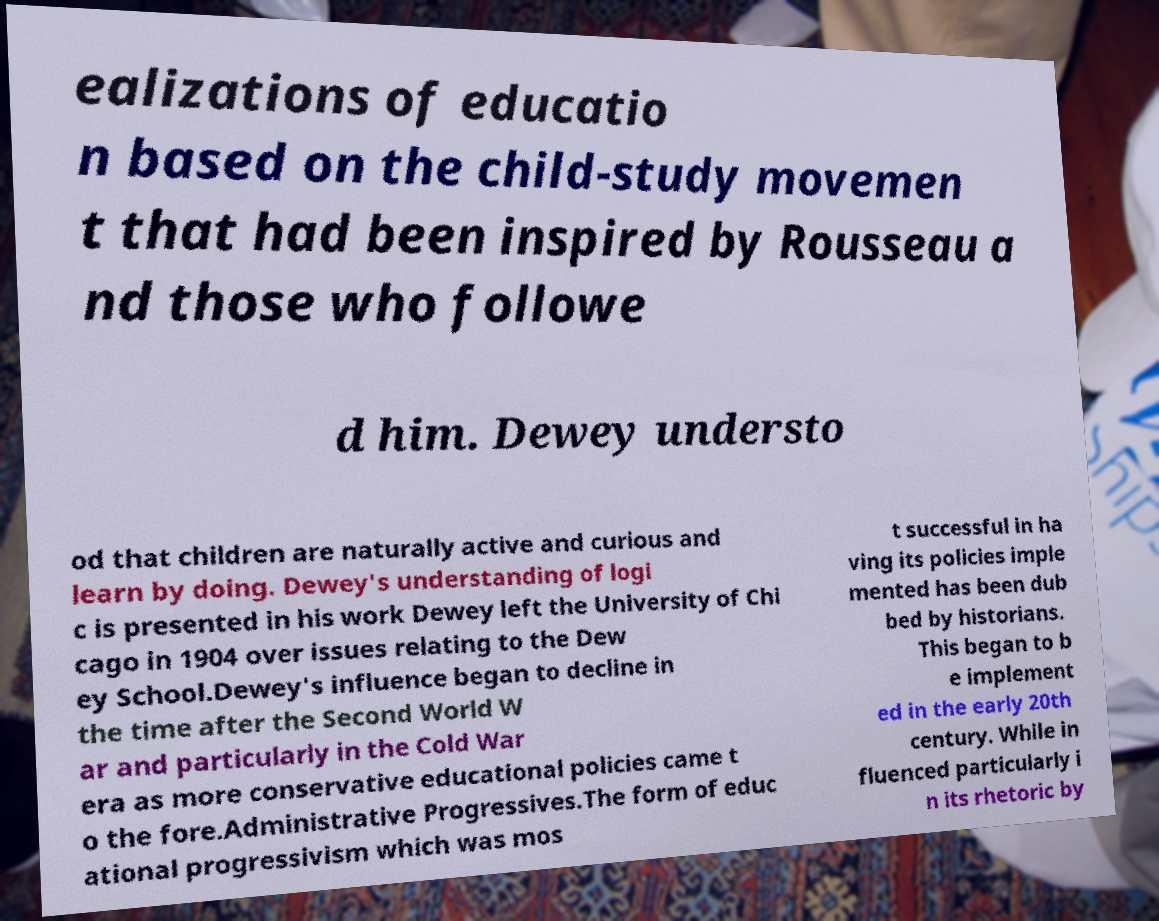For documentation purposes, I need the text within this image transcribed. Could you provide that? ealizations of educatio n based on the child-study movemen t that had been inspired by Rousseau a nd those who followe d him. Dewey understo od that children are naturally active and curious and learn by doing. Dewey's understanding of logi c is presented in his work Dewey left the University of Chi cago in 1904 over issues relating to the Dew ey School.Dewey's influence began to decline in the time after the Second World W ar and particularly in the Cold War era as more conservative educational policies came t o the fore.Administrative Progressives.The form of educ ational progressivism which was mos t successful in ha ving its policies imple mented has been dub bed by historians. This began to b e implement ed in the early 20th century. While in fluenced particularly i n its rhetoric by 